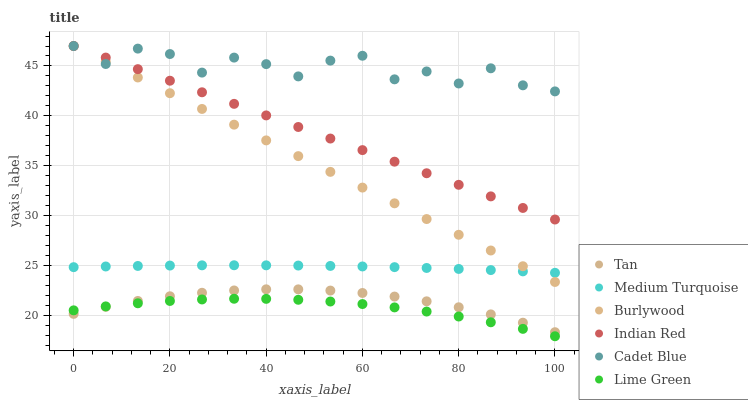Does Lime Green have the minimum area under the curve?
Answer yes or no. Yes. Does Cadet Blue have the maximum area under the curve?
Answer yes or no. Yes. Does Medium Turquoise have the minimum area under the curve?
Answer yes or no. No. Does Medium Turquoise have the maximum area under the curve?
Answer yes or no. No. Is Indian Red the smoothest?
Answer yes or no. Yes. Is Cadet Blue the roughest?
Answer yes or no. Yes. Is Medium Turquoise the smoothest?
Answer yes or no. No. Is Medium Turquoise the roughest?
Answer yes or no. No. Does Lime Green have the lowest value?
Answer yes or no. Yes. Does Medium Turquoise have the lowest value?
Answer yes or no. No. Does Indian Red have the highest value?
Answer yes or no. Yes. Does Medium Turquoise have the highest value?
Answer yes or no. No. Is Medium Turquoise less than Cadet Blue?
Answer yes or no. Yes. Is Cadet Blue greater than Lime Green?
Answer yes or no. Yes. Does Cadet Blue intersect Burlywood?
Answer yes or no. Yes. Is Cadet Blue less than Burlywood?
Answer yes or no. No. Is Cadet Blue greater than Burlywood?
Answer yes or no. No. Does Medium Turquoise intersect Cadet Blue?
Answer yes or no. No. 